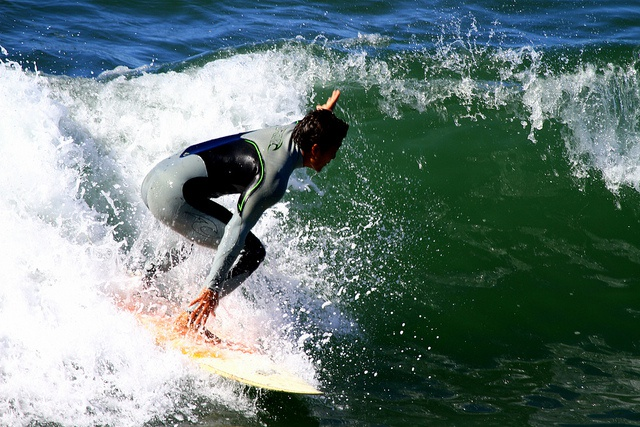Describe the objects in this image and their specific colors. I can see people in darkblue, black, darkgray, lightgray, and gray tones and surfboard in darkblue, ivory, tan, lightpink, and darkgray tones in this image. 